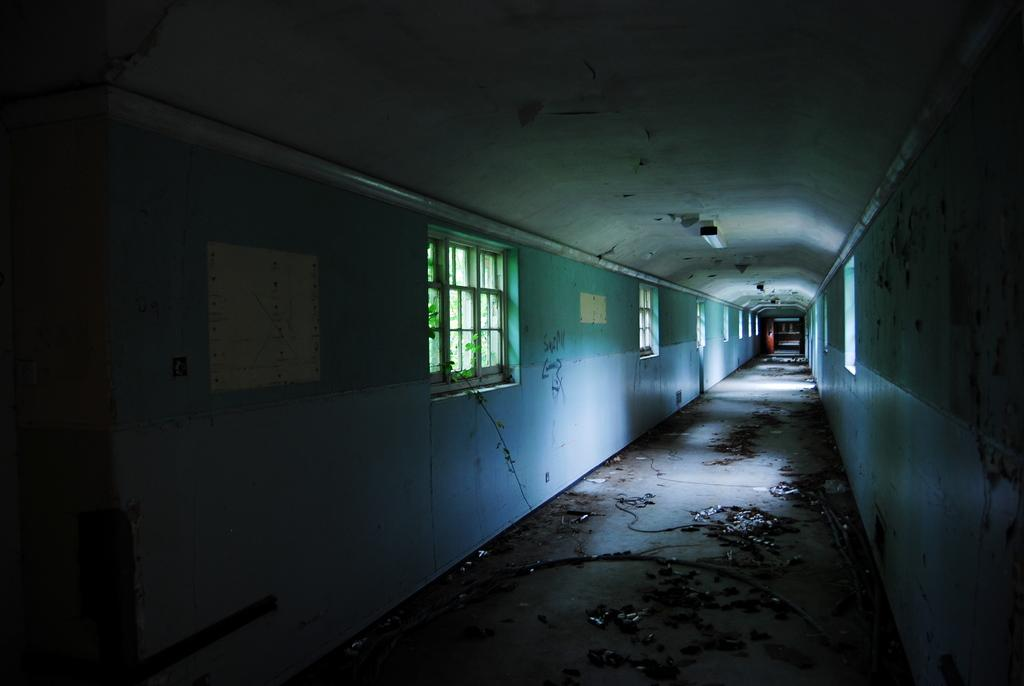What type of structures can be seen in the image? There are walls in the image. What can be seen through the walls in the image? There are windows in the image. What type of vegetation is present in the image? There are plants in the image. What is the ground made of in the image? There is dirt on the ground in the image. What is visible above the walls in the image? The ceiling is visible in the image. What provides illumination in the image? There is a light in the image. What type of humor can be seen in the image? There is no humor present in the image; it is a scene with walls, windows, plants, dirt, the ceiling, and a light. 